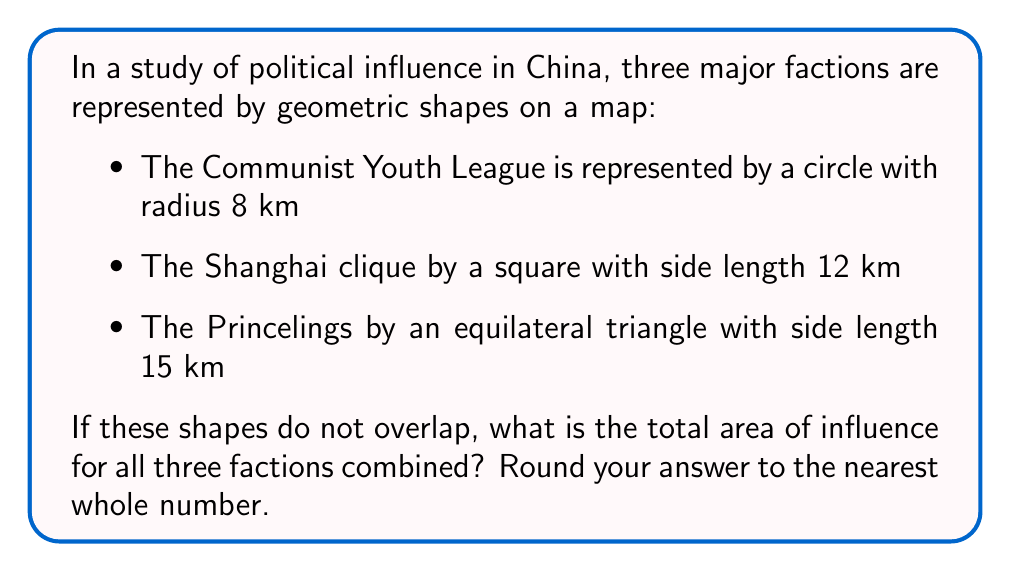Solve this math problem. To solve this problem, we need to calculate the area of each shape and then sum them up:

1. Area of the circle (Communist Youth League):
   $$A_c = \pi r^2 = \pi (8^2) = 64\pi \approx 201.06 \text{ km}^2$$

2. Area of the square (Shanghai clique):
   $$A_s = s^2 = 12^2 = 144 \text{ km}^2$$

3. Area of the equilateral triangle (Princelings):
   The area of an equilateral triangle is given by:
   $$A_t = \frac{\sqrt{3}}{4}a^2$$
   where $a$ is the side length.
   $$A_t = \frac{\sqrt{3}}{4}(15^2) = \frac{225\sqrt{3}}{4} \approx 97.43 \text{ km}^2$$

4. Total area:
   $$A_{\text{total}} = A_c + A_s + A_t$$
   $$A_{\text{total}} \approx 201.06 + 144 + 97.43 = 442.49 \text{ km}^2$$

5. Rounding to the nearest whole number:
   $$A_{\text{total}} \approx 442 \text{ km}^2$$
Answer: 442 km² 